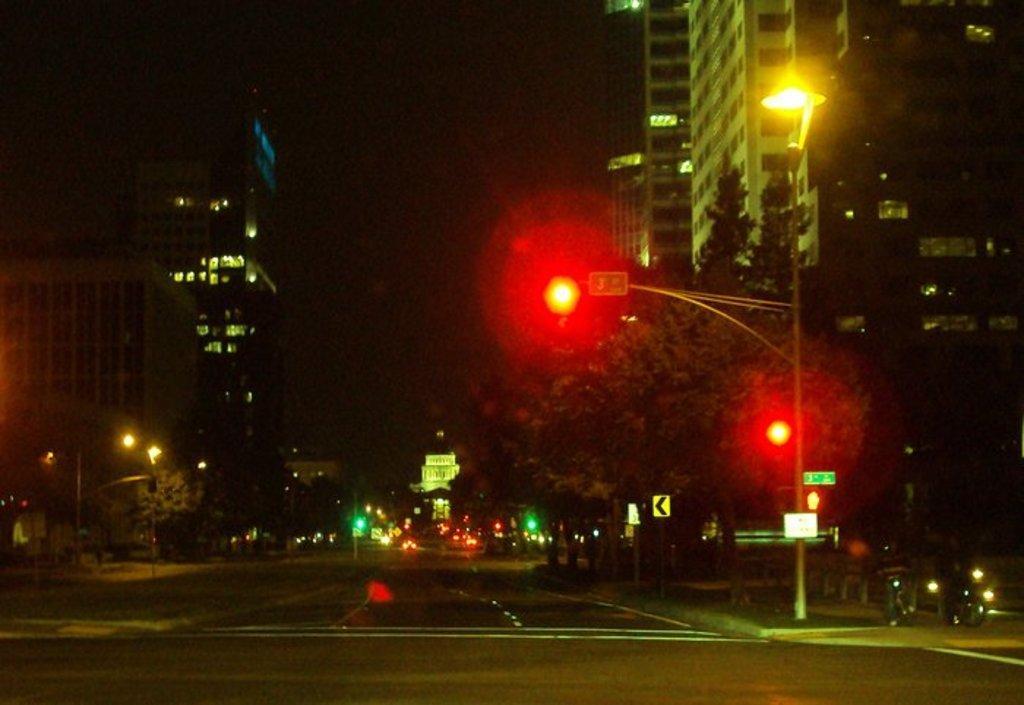Could you give a brief overview of what you see in this image? The picture is captured in the night time, there are traffic signal lights, street lights and around the street lights there are many trees, there are a lot of buildings around the road and on the right side of the traffic signal pole there are few vehicles beside the footpath. 